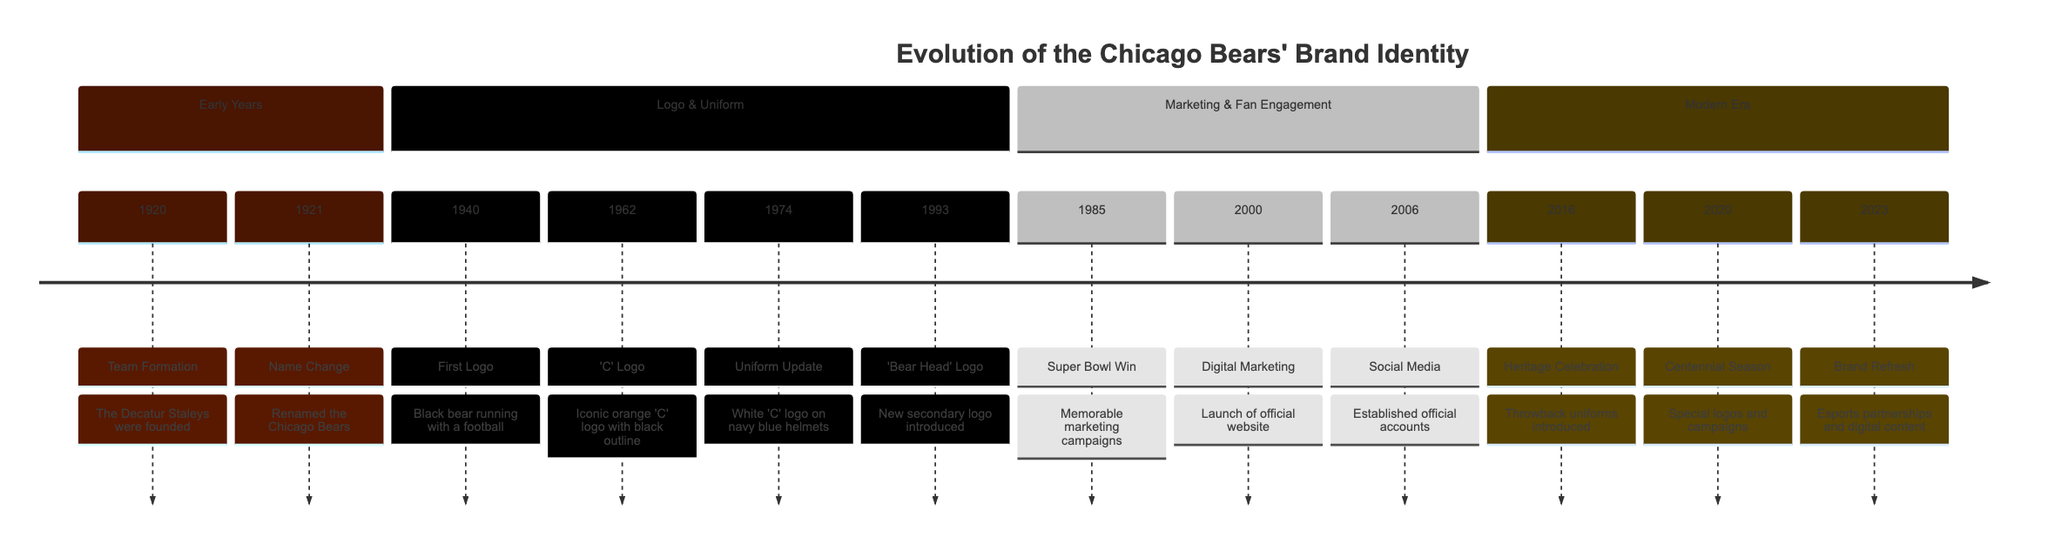What year was the Chicago Bears founded? The diagram shows the team formation event in 1920 as the year the Decatur Staleys were founded, which later became the Chicago Bears.
Answer: 1920 What logo was introduced in 1962? In the diagram, the entry for the year 1962 indicates the debut of the iconic orange 'C' logo.
Answer: 'C' Logo How many significant logo changes are indicated in the timeline? By counting the distinct logo events listed (First Logo, 'C' Logo, and 'Bear Head' Logo), there are three major changes shown in the timeline.
Answer: 3 What was a key marketing event in 1985? According to the timeline, in 1985 a memorable marketing campaign was launched celebrating the Bears' Super Bowl XX victory, which stands out as significant.
Answer: Super Bowl Win Which year marks the introduction of social media presence for the team? The entry for 2006 specifically states that the Bears established official social media accounts, indicating this as the year they entered that space.
Answer: 2006 What type of initiatives were launched in 2000? The timeline details that in 2000, digital marketing initiatives began with the launch of the official website.
Answer: Digital Marketing Initiatives How did the Bears celebrate their 100th anniversary in 2020? The diagram states that in 2020, special logos, uniforms, and marketing campaigns were rolled out to honor the centennial season of the Bears, highlighting their history.
Answer: Centennial Season What does the 2023 event reflect in terms of audience engagement? The entry for 2023 shows initiatives aimed at engaging a younger audience through esports partnerships and innovative digital content, indicating a shift towards modern engagement strategies.
Answer: Modern Brand Refresh What is the frequency of logo changes mentioned in the timeline? The timeline features four distinct logo-related events across the years provided, demonstrating the Bears' evolving brand identity in this aspect.
Answer: 4 What event marks the introduction of throwback uniforms? The diagram indicates that throwback uniforms were introduced in 2016 as a form of honoring the team's heritage, marking an important moment in the history of their brand identity.
Answer: Heritage Celebration 